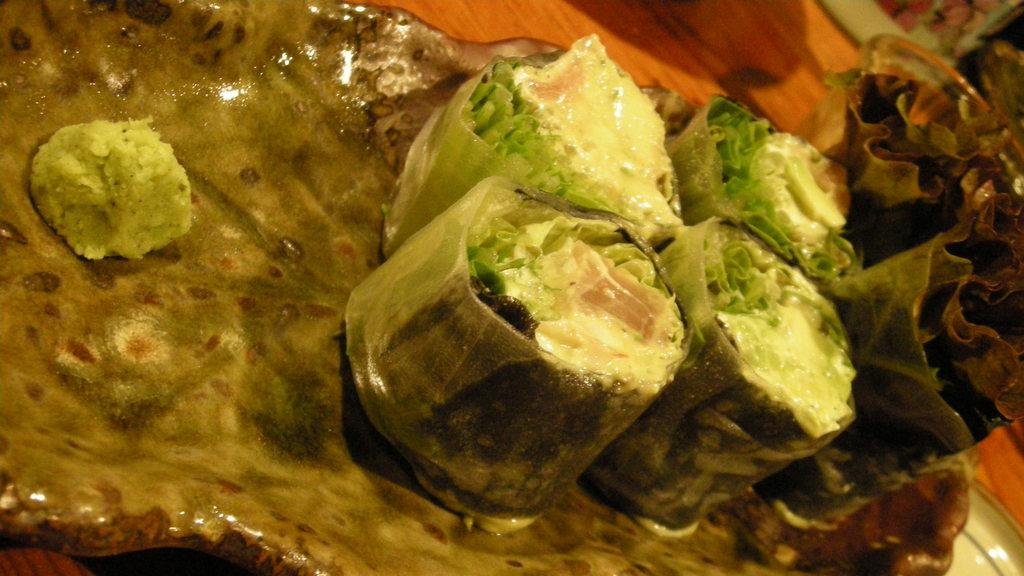What is on the plate that is visible on the table in the image? There is a plate with food items on a table in the image. What else can be seen on the table besides the plate with food items? There are other items on the table in the image. What advice can be seen written on the trees in the image? There are no trees present in the image, and therefore no advice can be seen written on them. 